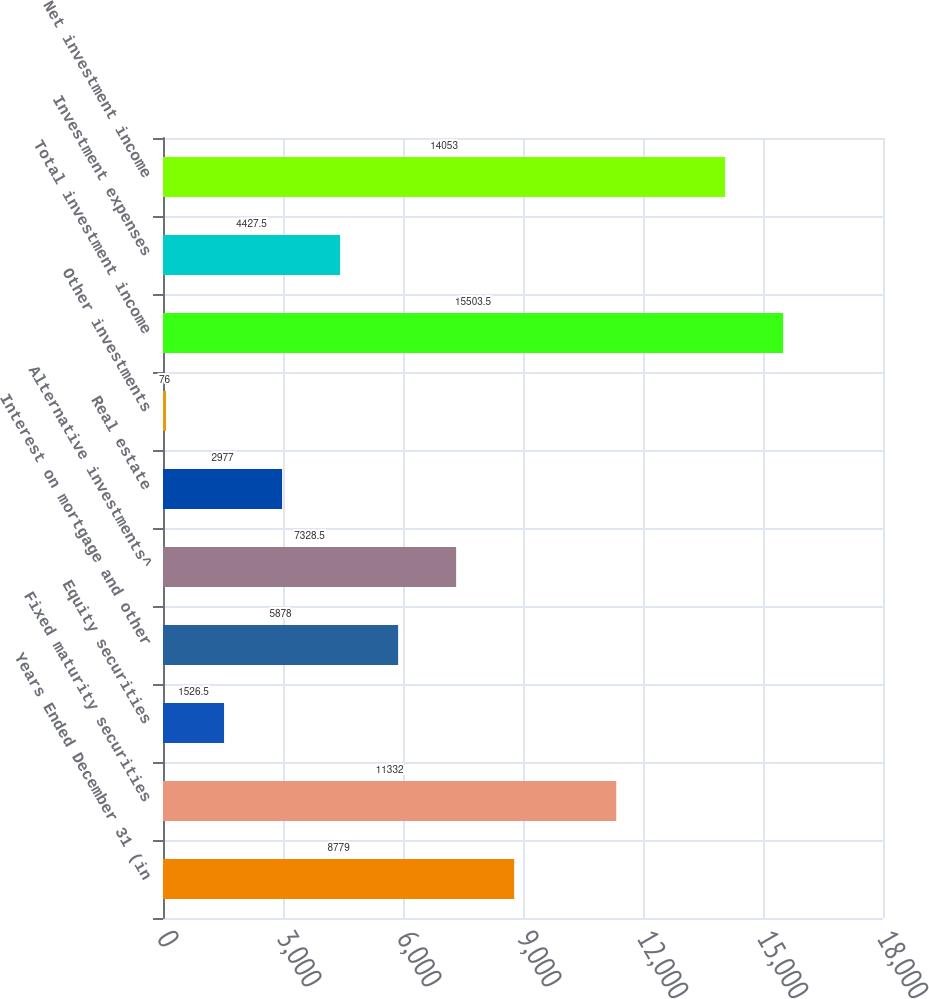Convert chart to OTSL. <chart><loc_0><loc_0><loc_500><loc_500><bar_chart><fcel>Years Ended December 31 (in<fcel>Fixed maturity securities<fcel>Equity securities<fcel>Interest on mortgage and other<fcel>Alternative investments^<fcel>Real estate<fcel>Other investments<fcel>Total investment income<fcel>Investment expenses<fcel>Net investment income<nl><fcel>8779<fcel>11332<fcel>1526.5<fcel>5878<fcel>7328.5<fcel>2977<fcel>76<fcel>15503.5<fcel>4427.5<fcel>14053<nl></chart> 